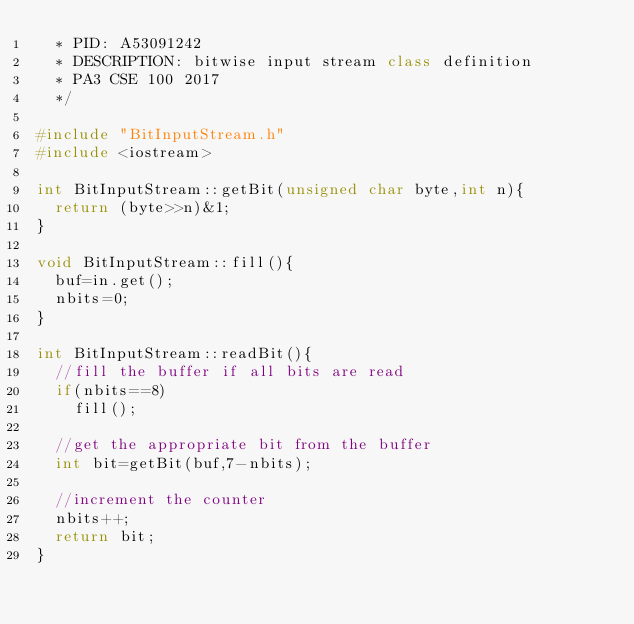Convert code to text. <code><loc_0><loc_0><loc_500><loc_500><_C++_>  * PID: A53091242
  * DESCRIPTION: bitwise input stream class definition
  * PA3 CSE 100 2017
  */

#include "BitInputStream.h"
#include <iostream>

int BitInputStream::getBit(unsigned char byte,int n){
  return (byte>>n)&1;
}

void BitInputStream::fill(){
  buf=in.get();
  nbits=0;
}

int BitInputStream::readBit(){
  //fill the buffer if all bits are read
  if(nbits==8)
    fill();

  //get the appropriate bit from the buffer
  int bit=getBit(buf,7-nbits);

  //increment the counter
  nbits++;
  return bit;
}
</code> 